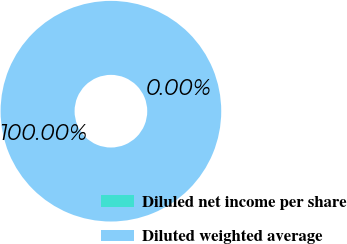<chart> <loc_0><loc_0><loc_500><loc_500><pie_chart><fcel>Diluled net income per share<fcel>Diluted weighted average<nl><fcel>0.0%<fcel>100.0%<nl></chart> 